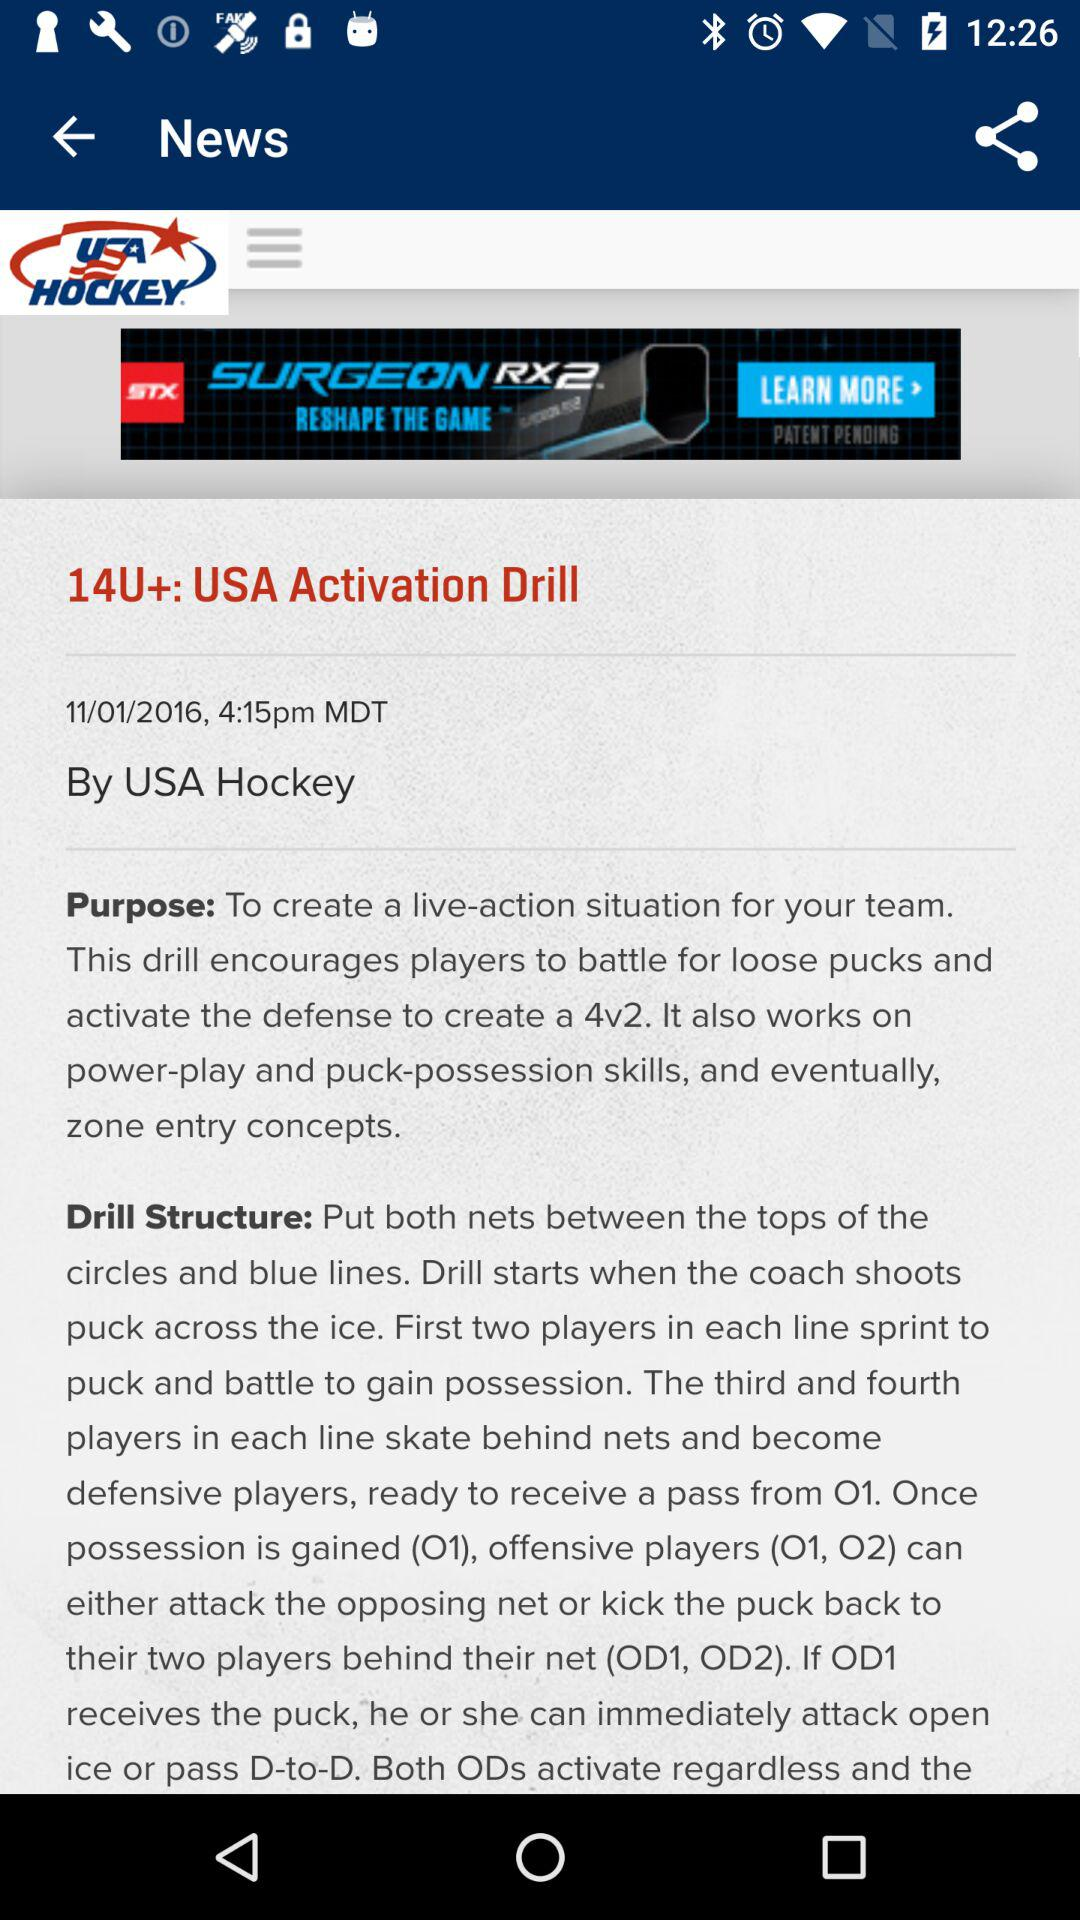What is the drill structure? The drill structure is "Put both nets between the tops of the circles and blue lines. Drill starts when the coach shoots puck across the ice. First two players in each line sprint to puck and battle to gain possession. The third and fourth players in each line skate behind nets and become defensive players, ready to receive a pass from O1. Once possession is gained (O1), offensive players (O1, O2) can either attack the opposing net or kick the puck back to their two players behind their net (OD1, OD2). If OD1 receives the puck, he or she can immediately attack open ice or pass D-to-D. Both ODs activate regardless and the". 